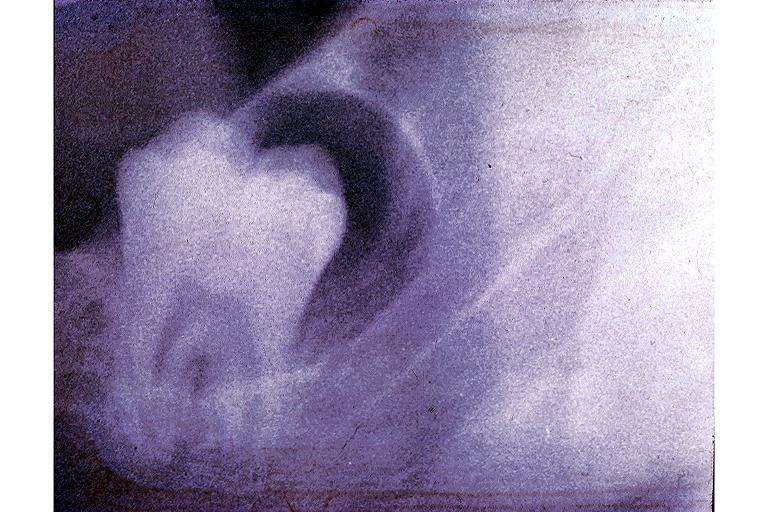what is present?
Answer the question using a single word or phrase. Oral 